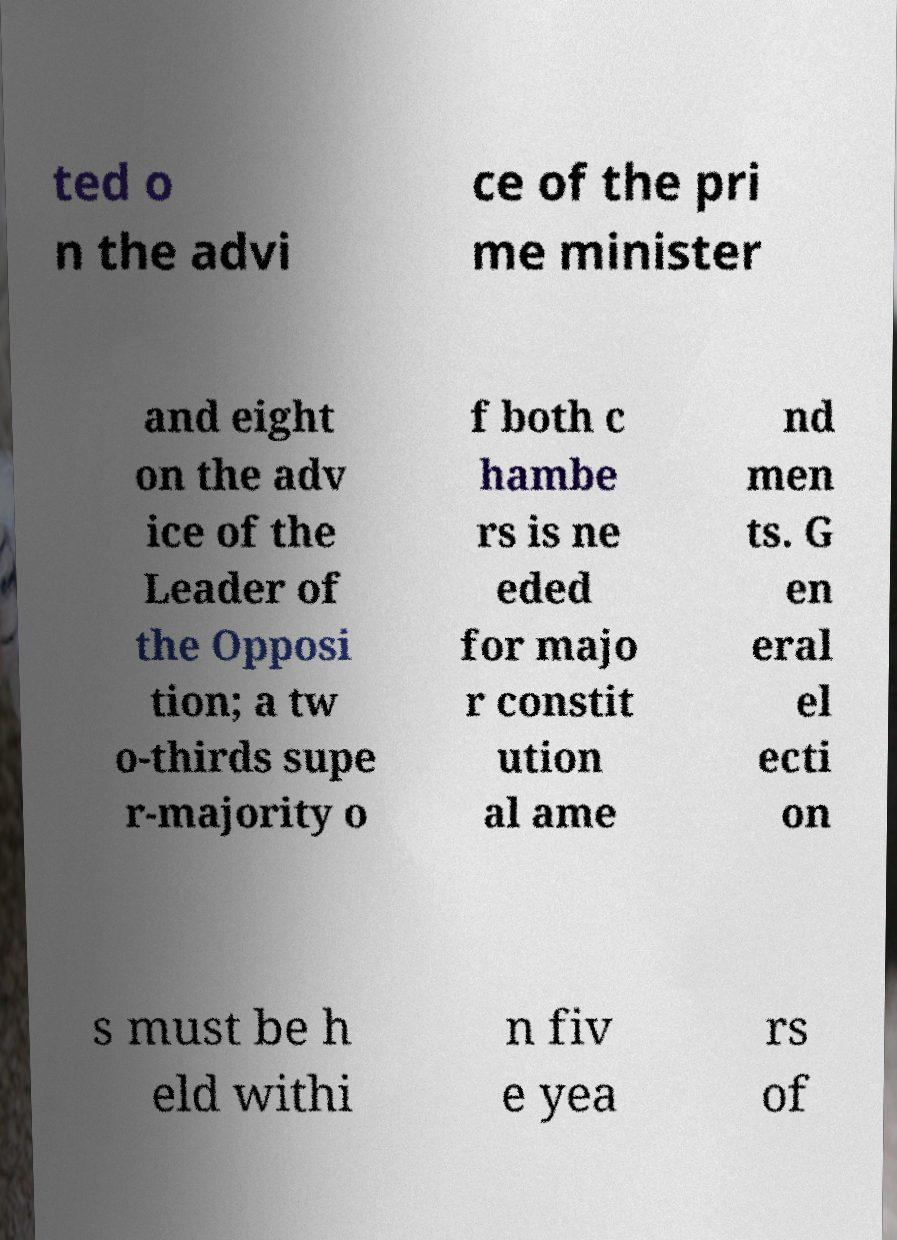Can you create a learning question about this image? Definitely! Based on the political theme of the text, one potential question could be: 'Why might a government require a two-thirds super-majority to amend its constitution, and how does this compare to a simple majority requirement?' 